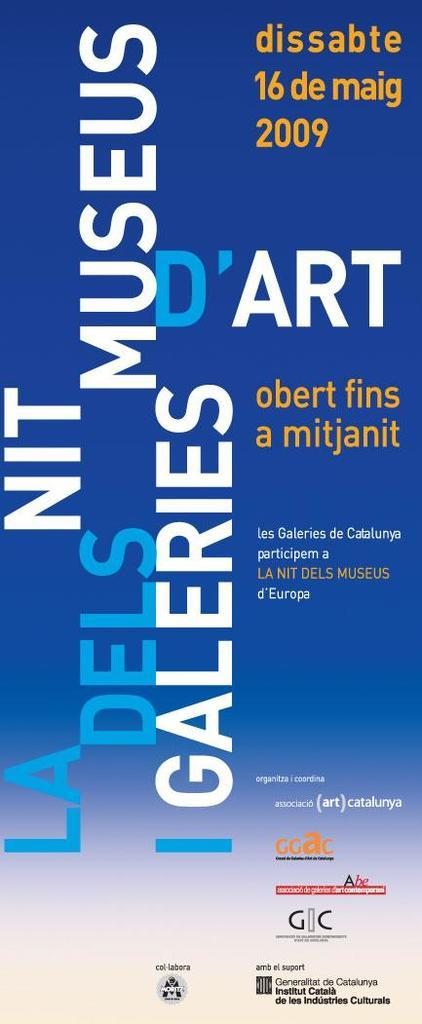<image>
Summarize the visual content of the image. A poster in blue which has the word 'd'art' on it in white. 